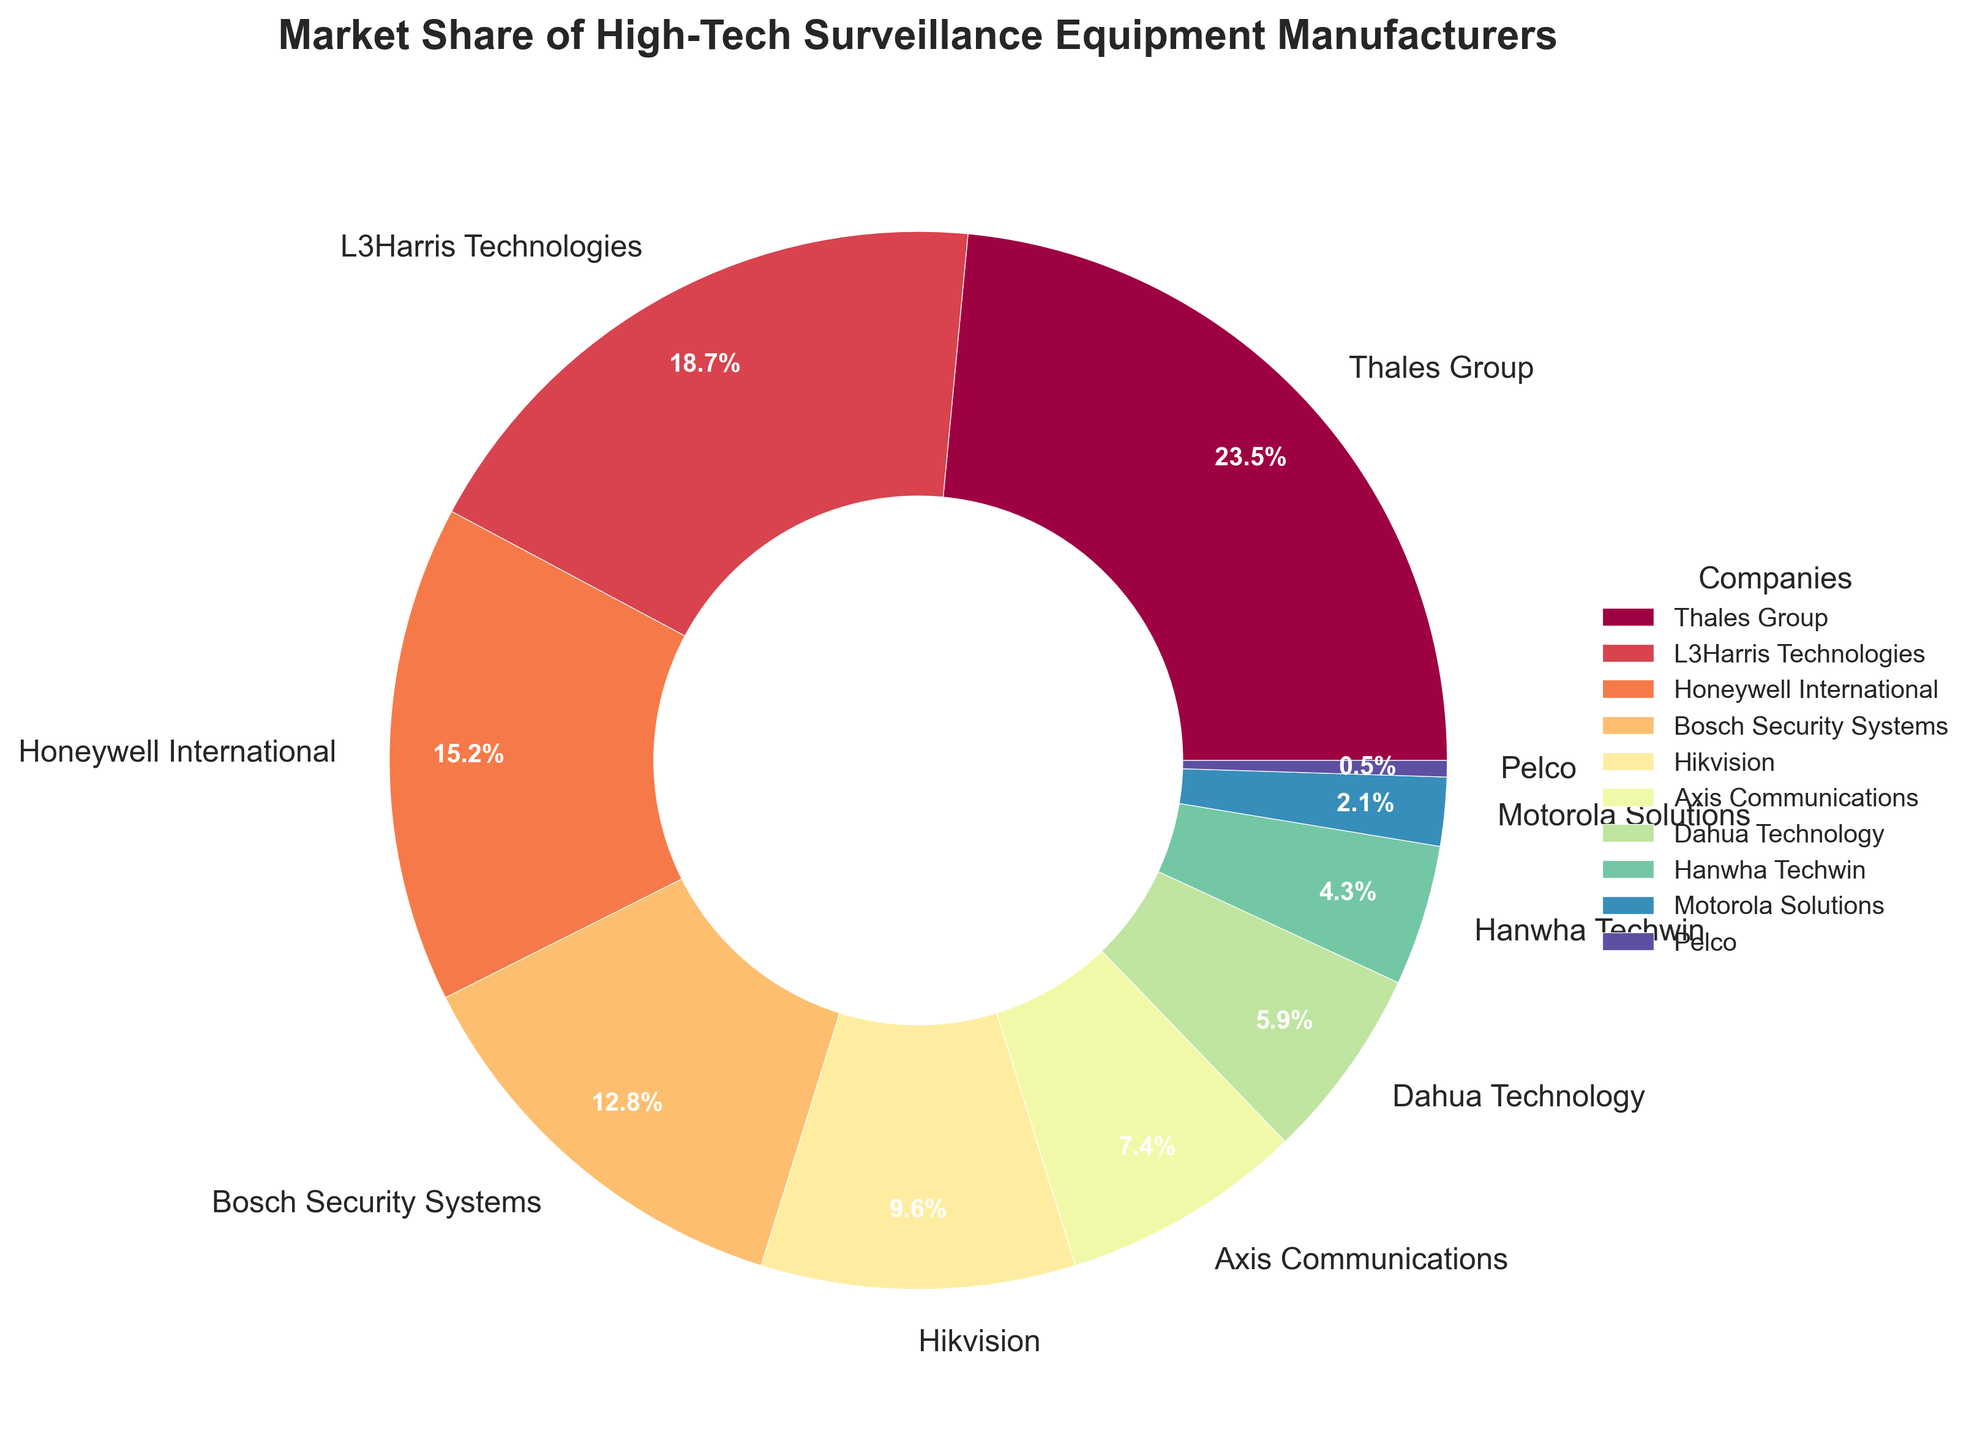What is the total market share of Thales Group and L3Harris Technologies combined? Add the market share percentages of Thales Group (23.5) and L3Harris Technologies (18.7). 23.5 + 18.7 = 42.2
Answer: 42.2% Which company has the smallest market share and what is that percentage? The company with the smallest market share is Pelco, with a market share of 0.5%.
Answer: Pelco, 0.5% How much larger is the market share of Thales Group compared to Axis Communications? Subtract the market share of Axis Communications (7.4%) from the market share of Thales Group (23.5%). 23.5 - 7.4 = 16.1
Answer: 16.1% What is the combined market share of the companies with less than 10% market share? Sum the market shares of Bosch Security Systems (12.8%), Hikvision (9.6%), Axis Communications (7.4%), Dahua Technology (5.9%), Hanwha Techwin (4.3%), Motorola Solutions (2.1%), and Pelco (0.5%). 9.6 + 7.4 + 5.9 + 4.3 + 2.1 + 0.5 = 29.8
Answer: 29.8% Which two companies together hold just over one-third of the market share? Add the percentages of Honeywell International (15.2%) and Bosch Security Systems (12.8%) to get close to one-third of the market share. 15.2 + 12.8 = 28, which is roughly a third of 100%.
Answer: Honeywell International and Bosch Security Systems What is the difference in market share between the company with the highest market share and the company with the second-highest market share? Thales Group has the highest market share at 23.5%, and L3Harris Technologies has the second-highest at 18.7%. Subtract 18.7% from 23.5%. 23.5 - 18.7 = 4.8
Answer: 4.8% How many companies have a market share greater than 10%? Review the market share data points and count the companies exceeding 10%: Thales Group (23.5%), L3Harris Technologies (18.7%), Honeywell International (15.2%), Bosch Security Systems (12.8%) - four companies.
Answer: 4 Which company appears on the pie chart with the darkest color? Without seeing the exact color map, usually, the largest segment, Thales Group, is represented by the darkest color in sequential color maps.
Answer: Thales Group 